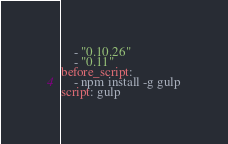Convert code to text. <code><loc_0><loc_0><loc_500><loc_500><_YAML_>    - "0.10.26"
    - "0.11"
before_script:
    - npm install -g gulp
script: gulp</code> 